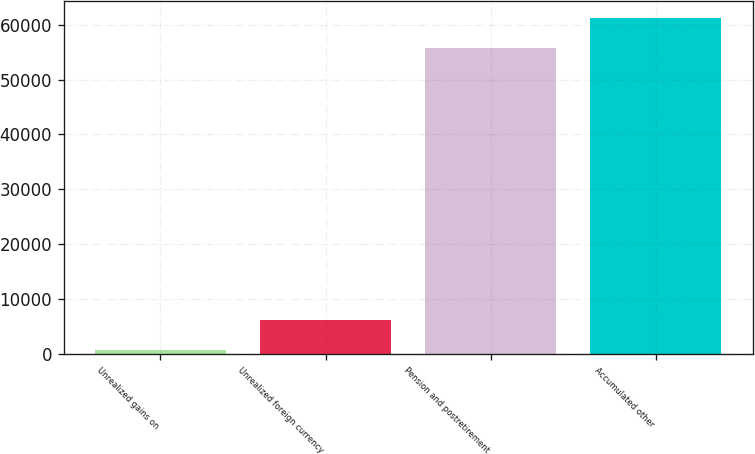Convert chart to OTSL. <chart><loc_0><loc_0><loc_500><loc_500><bar_chart><fcel>Unrealized gains on<fcel>Unrealized foreign currency<fcel>Pension and postretirement<fcel>Accumulated other<nl><fcel>725<fcel>6232.8<fcel>55736<fcel>61243.8<nl></chart> 